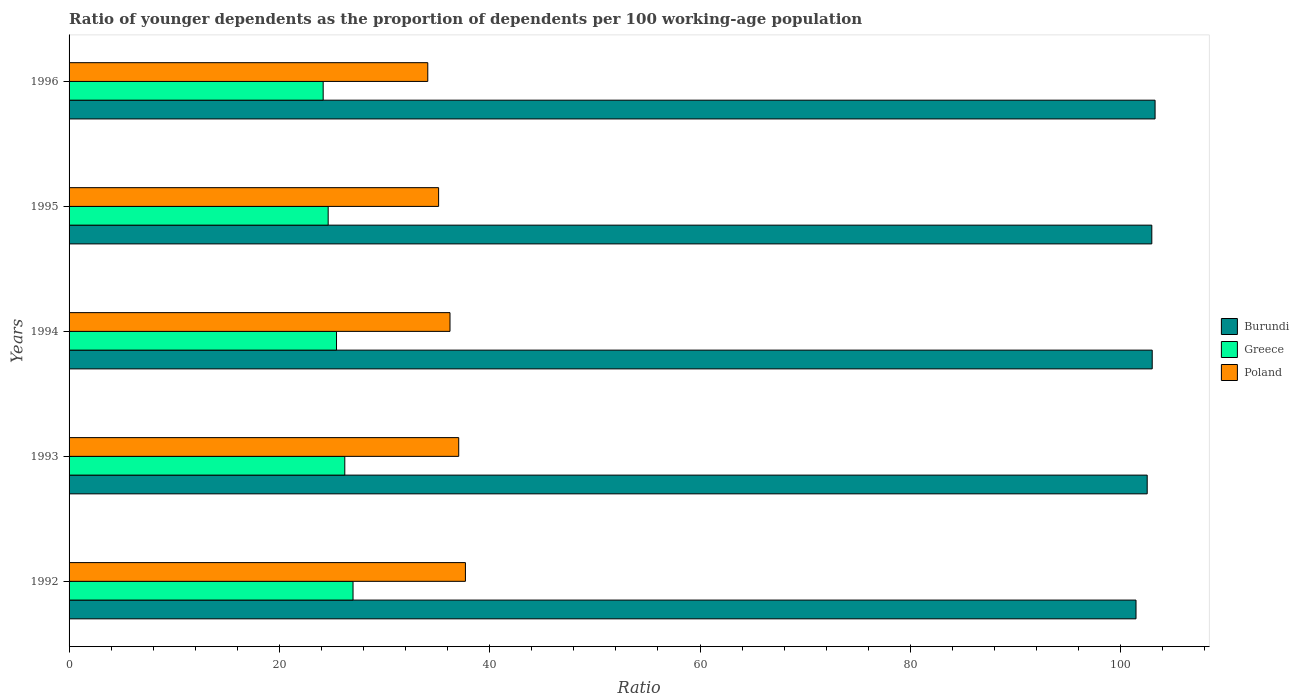How many bars are there on the 1st tick from the top?
Provide a short and direct response. 3. How many bars are there on the 3rd tick from the bottom?
Ensure brevity in your answer.  3. What is the label of the 4th group of bars from the top?
Your answer should be very brief. 1993. What is the age dependency ratio(young) in Greece in 1992?
Your response must be concise. 27. Across all years, what is the maximum age dependency ratio(young) in Burundi?
Your answer should be very brief. 103.27. Across all years, what is the minimum age dependency ratio(young) in Burundi?
Your response must be concise. 101.46. In which year was the age dependency ratio(young) in Burundi maximum?
Your response must be concise. 1996. In which year was the age dependency ratio(young) in Greece minimum?
Your response must be concise. 1996. What is the total age dependency ratio(young) in Burundi in the graph?
Give a very brief answer. 513.22. What is the difference between the age dependency ratio(young) in Greece in 1992 and that in 1994?
Ensure brevity in your answer.  1.57. What is the difference between the age dependency ratio(young) in Greece in 1994 and the age dependency ratio(young) in Poland in 1995?
Make the answer very short. -9.71. What is the average age dependency ratio(young) in Poland per year?
Provide a short and direct response. 36.04. In the year 1994, what is the difference between the age dependency ratio(young) in Burundi and age dependency ratio(young) in Poland?
Offer a terse response. 66.78. What is the ratio of the age dependency ratio(young) in Burundi in 1993 to that in 1996?
Keep it short and to the point. 0.99. Is the age dependency ratio(young) in Poland in 1995 less than that in 1996?
Ensure brevity in your answer.  No. What is the difference between the highest and the second highest age dependency ratio(young) in Burundi?
Your response must be concise. 0.27. What is the difference between the highest and the lowest age dependency ratio(young) in Burundi?
Keep it short and to the point. 1.81. Is the sum of the age dependency ratio(young) in Poland in 1992 and 1996 greater than the maximum age dependency ratio(young) in Burundi across all years?
Give a very brief answer. No. What does the 1st bar from the bottom in 1996 represents?
Provide a short and direct response. Burundi. Are all the bars in the graph horizontal?
Provide a short and direct response. Yes. How many years are there in the graph?
Give a very brief answer. 5. Does the graph contain any zero values?
Make the answer very short. No. Does the graph contain grids?
Make the answer very short. No. Where does the legend appear in the graph?
Offer a terse response. Center right. How many legend labels are there?
Offer a terse response. 3. How are the legend labels stacked?
Your response must be concise. Vertical. What is the title of the graph?
Offer a very short reply. Ratio of younger dependents as the proportion of dependents per 100 working-age population. What is the label or title of the X-axis?
Make the answer very short. Ratio. What is the Ratio in Burundi in 1992?
Make the answer very short. 101.46. What is the Ratio of Greece in 1992?
Your answer should be compact. 27. What is the Ratio of Poland in 1992?
Offer a terse response. 37.69. What is the Ratio of Burundi in 1993?
Keep it short and to the point. 102.52. What is the Ratio in Greece in 1993?
Offer a very short reply. 26.22. What is the Ratio of Poland in 1993?
Your response must be concise. 37.05. What is the Ratio of Burundi in 1994?
Your response must be concise. 103. What is the Ratio in Greece in 1994?
Make the answer very short. 25.43. What is the Ratio of Poland in 1994?
Provide a succinct answer. 36.22. What is the Ratio of Burundi in 1995?
Offer a terse response. 102.96. What is the Ratio in Greece in 1995?
Make the answer very short. 24.64. What is the Ratio in Poland in 1995?
Ensure brevity in your answer.  35.14. What is the Ratio of Burundi in 1996?
Make the answer very short. 103.27. What is the Ratio in Greece in 1996?
Your answer should be very brief. 24.16. What is the Ratio of Poland in 1996?
Make the answer very short. 34.11. Across all years, what is the maximum Ratio in Burundi?
Provide a short and direct response. 103.27. Across all years, what is the maximum Ratio of Greece?
Make the answer very short. 27. Across all years, what is the maximum Ratio in Poland?
Give a very brief answer. 37.69. Across all years, what is the minimum Ratio of Burundi?
Make the answer very short. 101.46. Across all years, what is the minimum Ratio in Greece?
Provide a short and direct response. 24.16. Across all years, what is the minimum Ratio in Poland?
Your response must be concise. 34.11. What is the total Ratio in Burundi in the graph?
Ensure brevity in your answer.  513.22. What is the total Ratio of Greece in the graph?
Offer a very short reply. 127.46. What is the total Ratio in Poland in the graph?
Your response must be concise. 180.22. What is the difference between the Ratio of Burundi in 1992 and that in 1993?
Make the answer very short. -1.06. What is the difference between the Ratio of Greece in 1992 and that in 1993?
Give a very brief answer. 0.78. What is the difference between the Ratio in Poland in 1992 and that in 1993?
Offer a very short reply. 0.64. What is the difference between the Ratio in Burundi in 1992 and that in 1994?
Your response must be concise. -1.54. What is the difference between the Ratio in Greece in 1992 and that in 1994?
Offer a terse response. 1.57. What is the difference between the Ratio in Poland in 1992 and that in 1994?
Make the answer very short. 1.47. What is the difference between the Ratio of Burundi in 1992 and that in 1995?
Your answer should be compact. -1.5. What is the difference between the Ratio of Greece in 1992 and that in 1995?
Give a very brief answer. 2.36. What is the difference between the Ratio in Poland in 1992 and that in 1995?
Offer a very short reply. 2.55. What is the difference between the Ratio of Burundi in 1992 and that in 1996?
Your answer should be very brief. -1.81. What is the difference between the Ratio in Greece in 1992 and that in 1996?
Make the answer very short. 2.84. What is the difference between the Ratio of Poland in 1992 and that in 1996?
Your response must be concise. 3.58. What is the difference between the Ratio in Burundi in 1993 and that in 1994?
Make the answer very short. -0.48. What is the difference between the Ratio in Greece in 1993 and that in 1994?
Give a very brief answer. 0.79. What is the difference between the Ratio in Poland in 1993 and that in 1994?
Your response must be concise. 0.83. What is the difference between the Ratio in Burundi in 1993 and that in 1995?
Keep it short and to the point. -0.44. What is the difference between the Ratio in Greece in 1993 and that in 1995?
Offer a very short reply. 1.58. What is the difference between the Ratio in Poland in 1993 and that in 1995?
Give a very brief answer. 1.91. What is the difference between the Ratio in Burundi in 1993 and that in 1996?
Your response must be concise. -0.75. What is the difference between the Ratio in Greece in 1993 and that in 1996?
Provide a short and direct response. 2.06. What is the difference between the Ratio of Poland in 1993 and that in 1996?
Keep it short and to the point. 2.94. What is the difference between the Ratio of Burundi in 1994 and that in 1995?
Give a very brief answer. 0.04. What is the difference between the Ratio in Greece in 1994 and that in 1995?
Offer a very short reply. 0.79. What is the difference between the Ratio in Poland in 1994 and that in 1995?
Make the answer very short. 1.08. What is the difference between the Ratio of Burundi in 1994 and that in 1996?
Your answer should be compact. -0.27. What is the difference between the Ratio of Greece in 1994 and that in 1996?
Offer a very short reply. 1.27. What is the difference between the Ratio in Poland in 1994 and that in 1996?
Provide a short and direct response. 2.11. What is the difference between the Ratio in Burundi in 1995 and that in 1996?
Ensure brevity in your answer.  -0.31. What is the difference between the Ratio of Greece in 1995 and that in 1996?
Provide a short and direct response. 0.48. What is the difference between the Ratio of Poland in 1995 and that in 1996?
Offer a terse response. 1.03. What is the difference between the Ratio in Burundi in 1992 and the Ratio in Greece in 1993?
Your answer should be very brief. 75.24. What is the difference between the Ratio in Burundi in 1992 and the Ratio in Poland in 1993?
Make the answer very short. 64.41. What is the difference between the Ratio in Greece in 1992 and the Ratio in Poland in 1993?
Offer a terse response. -10.05. What is the difference between the Ratio in Burundi in 1992 and the Ratio in Greece in 1994?
Make the answer very short. 76.03. What is the difference between the Ratio in Burundi in 1992 and the Ratio in Poland in 1994?
Offer a terse response. 65.24. What is the difference between the Ratio in Greece in 1992 and the Ratio in Poland in 1994?
Offer a very short reply. -9.22. What is the difference between the Ratio of Burundi in 1992 and the Ratio of Greece in 1995?
Your answer should be compact. 76.82. What is the difference between the Ratio in Burundi in 1992 and the Ratio in Poland in 1995?
Offer a very short reply. 66.32. What is the difference between the Ratio of Greece in 1992 and the Ratio of Poland in 1995?
Offer a very short reply. -8.14. What is the difference between the Ratio in Burundi in 1992 and the Ratio in Greece in 1996?
Ensure brevity in your answer.  77.3. What is the difference between the Ratio in Burundi in 1992 and the Ratio in Poland in 1996?
Give a very brief answer. 67.35. What is the difference between the Ratio of Greece in 1992 and the Ratio of Poland in 1996?
Provide a succinct answer. -7.11. What is the difference between the Ratio in Burundi in 1993 and the Ratio in Greece in 1994?
Provide a succinct answer. 77.09. What is the difference between the Ratio in Burundi in 1993 and the Ratio in Poland in 1994?
Give a very brief answer. 66.3. What is the difference between the Ratio in Greece in 1993 and the Ratio in Poland in 1994?
Your answer should be compact. -10. What is the difference between the Ratio of Burundi in 1993 and the Ratio of Greece in 1995?
Ensure brevity in your answer.  77.88. What is the difference between the Ratio of Burundi in 1993 and the Ratio of Poland in 1995?
Keep it short and to the point. 67.38. What is the difference between the Ratio of Greece in 1993 and the Ratio of Poland in 1995?
Offer a very short reply. -8.92. What is the difference between the Ratio in Burundi in 1993 and the Ratio in Greece in 1996?
Ensure brevity in your answer.  78.36. What is the difference between the Ratio of Burundi in 1993 and the Ratio of Poland in 1996?
Provide a succinct answer. 68.41. What is the difference between the Ratio of Greece in 1993 and the Ratio of Poland in 1996?
Your answer should be compact. -7.89. What is the difference between the Ratio in Burundi in 1994 and the Ratio in Greece in 1995?
Provide a succinct answer. 78.36. What is the difference between the Ratio in Burundi in 1994 and the Ratio in Poland in 1995?
Keep it short and to the point. 67.86. What is the difference between the Ratio in Greece in 1994 and the Ratio in Poland in 1995?
Offer a terse response. -9.71. What is the difference between the Ratio in Burundi in 1994 and the Ratio in Greece in 1996?
Offer a terse response. 78.84. What is the difference between the Ratio in Burundi in 1994 and the Ratio in Poland in 1996?
Your answer should be very brief. 68.89. What is the difference between the Ratio in Greece in 1994 and the Ratio in Poland in 1996?
Offer a terse response. -8.68. What is the difference between the Ratio of Burundi in 1995 and the Ratio of Greece in 1996?
Give a very brief answer. 78.8. What is the difference between the Ratio in Burundi in 1995 and the Ratio in Poland in 1996?
Provide a short and direct response. 68.85. What is the difference between the Ratio of Greece in 1995 and the Ratio of Poland in 1996?
Ensure brevity in your answer.  -9.47. What is the average Ratio in Burundi per year?
Give a very brief answer. 102.64. What is the average Ratio in Greece per year?
Make the answer very short. 25.49. What is the average Ratio of Poland per year?
Give a very brief answer. 36.04. In the year 1992, what is the difference between the Ratio in Burundi and Ratio in Greece?
Your answer should be compact. 74.46. In the year 1992, what is the difference between the Ratio in Burundi and Ratio in Poland?
Give a very brief answer. 63.77. In the year 1992, what is the difference between the Ratio of Greece and Ratio of Poland?
Make the answer very short. -10.69. In the year 1993, what is the difference between the Ratio in Burundi and Ratio in Greece?
Make the answer very short. 76.3. In the year 1993, what is the difference between the Ratio in Burundi and Ratio in Poland?
Ensure brevity in your answer.  65.47. In the year 1993, what is the difference between the Ratio in Greece and Ratio in Poland?
Ensure brevity in your answer.  -10.83. In the year 1994, what is the difference between the Ratio of Burundi and Ratio of Greece?
Keep it short and to the point. 77.57. In the year 1994, what is the difference between the Ratio in Burundi and Ratio in Poland?
Give a very brief answer. 66.78. In the year 1994, what is the difference between the Ratio in Greece and Ratio in Poland?
Provide a short and direct response. -10.79. In the year 1995, what is the difference between the Ratio in Burundi and Ratio in Greece?
Your answer should be compact. 78.32. In the year 1995, what is the difference between the Ratio in Burundi and Ratio in Poland?
Provide a succinct answer. 67.82. In the year 1995, what is the difference between the Ratio of Greece and Ratio of Poland?
Ensure brevity in your answer.  -10.5. In the year 1996, what is the difference between the Ratio of Burundi and Ratio of Greece?
Your answer should be very brief. 79.11. In the year 1996, what is the difference between the Ratio in Burundi and Ratio in Poland?
Make the answer very short. 69.16. In the year 1996, what is the difference between the Ratio of Greece and Ratio of Poland?
Ensure brevity in your answer.  -9.95. What is the ratio of the Ratio in Greece in 1992 to that in 1993?
Offer a very short reply. 1.03. What is the ratio of the Ratio in Poland in 1992 to that in 1993?
Offer a terse response. 1.02. What is the ratio of the Ratio in Burundi in 1992 to that in 1994?
Your response must be concise. 0.98. What is the ratio of the Ratio of Greece in 1992 to that in 1994?
Make the answer very short. 1.06. What is the ratio of the Ratio of Poland in 1992 to that in 1994?
Ensure brevity in your answer.  1.04. What is the ratio of the Ratio of Burundi in 1992 to that in 1995?
Offer a terse response. 0.99. What is the ratio of the Ratio of Greece in 1992 to that in 1995?
Ensure brevity in your answer.  1.1. What is the ratio of the Ratio in Poland in 1992 to that in 1995?
Provide a short and direct response. 1.07. What is the ratio of the Ratio of Burundi in 1992 to that in 1996?
Provide a short and direct response. 0.98. What is the ratio of the Ratio in Greece in 1992 to that in 1996?
Provide a short and direct response. 1.12. What is the ratio of the Ratio of Poland in 1992 to that in 1996?
Offer a very short reply. 1.1. What is the ratio of the Ratio in Greece in 1993 to that in 1994?
Provide a short and direct response. 1.03. What is the ratio of the Ratio of Poland in 1993 to that in 1994?
Provide a succinct answer. 1.02. What is the ratio of the Ratio of Burundi in 1993 to that in 1995?
Offer a terse response. 1. What is the ratio of the Ratio of Greece in 1993 to that in 1995?
Offer a very short reply. 1.06. What is the ratio of the Ratio of Poland in 1993 to that in 1995?
Provide a succinct answer. 1.05. What is the ratio of the Ratio of Burundi in 1993 to that in 1996?
Make the answer very short. 0.99. What is the ratio of the Ratio in Greece in 1993 to that in 1996?
Provide a short and direct response. 1.09. What is the ratio of the Ratio in Poland in 1993 to that in 1996?
Ensure brevity in your answer.  1.09. What is the ratio of the Ratio in Burundi in 1994 to that in 1995?
Offer a very short reply. 1. What is the ratio of the Ratio of Greece in 1994 to that in 1995?
Keep it short and to the point. 1.03. What is the ratio of the Ratio of Poland in 1994 to that in 1995?
Give a very brief answer. 1.03. What is the ratio of the Ratio of Greece in 1994 to that in 1996?
Your answer should be very brief. 1.05. What is the ratio of the Ratio in Poland in 1994 to that in 1996?
Give a very brief answer. 1.06. What is the ratio of the Ratio of Greece in 1995 to that in 1996?
Provide a short and direct response. 1.02. What is the ratio of the Ratio of Poland in 1995 to that in 1996?
Provide a succinct answer. 1.03. What is the difference between the highest and the second highest Ratio in Burundi?
Offer a terse response. 0.27. What is the difference between the highest and the second highest Ratio in Greece?
Make the answer very short. 0.78. What is the difference between the highest and the second highest Ratio in Poland?
Your answer should be very brief. 0.64. What is the difference between the highest and the lowest Ratio of Burundi?
Ensure brevity in your answer.  1.81. What is the difference between the highest and the lowest Ratio in Greece?
Your answer should be compact. 2.84. What is the difference between the highest and the lowest Ratio of Poland?
Offer a very short reply. 3.58. 